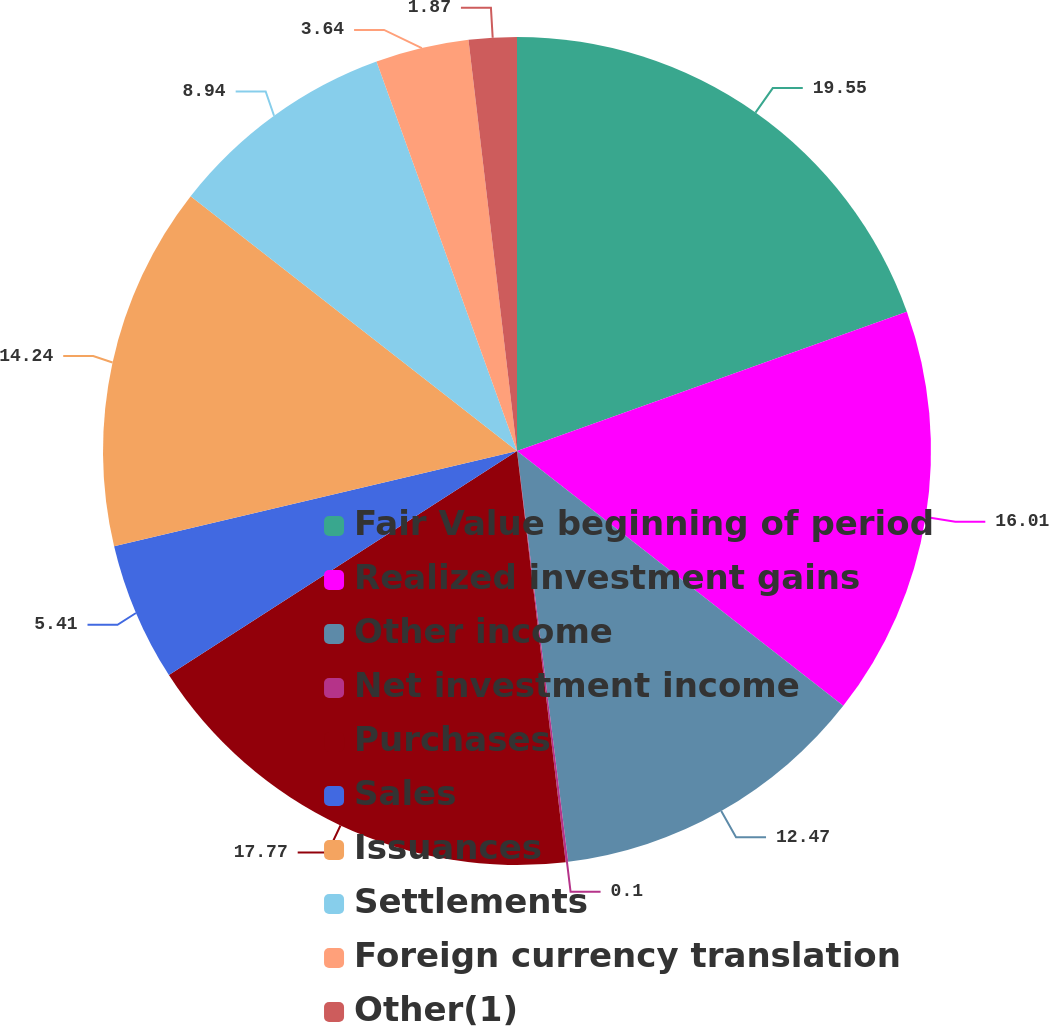<chart> <loc_0><loc_0><loc_500><loc_500><pie_chart><fcel>Fair Value beginning of period<fcel>Realized investment gains<fcel>Other income<fcel>Net investment income<fcel>Purchases<fcel>Sales<fcel>Issuances<fcel>Settlements<fcel>Foreign currency translation<fcel>Other(1)<nl><fcel>19.54%<fcel>16.01%<fcel>12.47%<fcel>0.1%<fcel>17.77%<fcel>5.41%<fcel>14.24%<fcel>8.94%<fcel>3.64%<fcel>1.87%<nl></chart> 